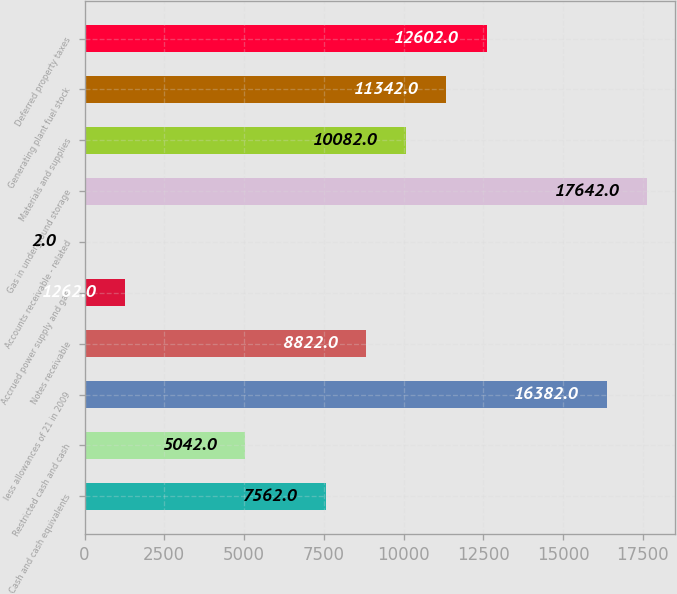<chart> <loc_0><loc_0><loc_500><loc_500><bar_chart><fcel>Cash and cash equivalents<fcel>Restricted cash and cash<fcel>less allowances of 21 in 2009<fcel>Notes receivable<fcel>Accrued power supply and gas<fcel>Accounts receivable - related<fcel>Gas in underground storage<fcel>Materials and supplies<fcel>Generating plant fuel stock<fcel>Deferred property taxes<nl><fcel>7562<fcel>5042<fcel>16382<fcel>8822<fcel>1262<fcel>2<fcel>17642<fcel>10082<fcel>11342<fcel>12602<nl></chart> 